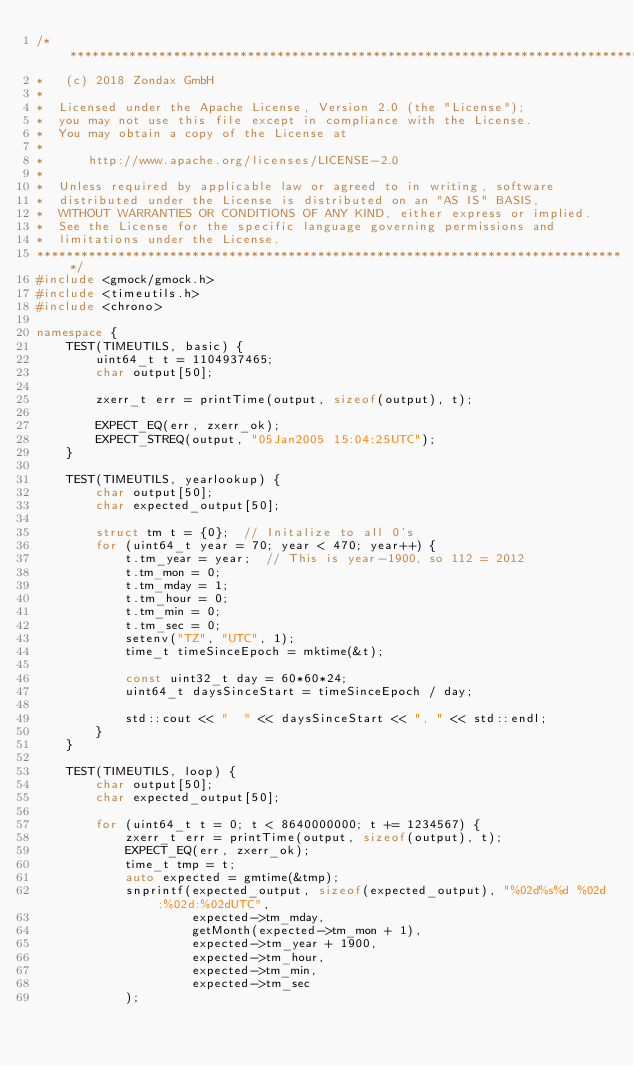<code> <loc_0><loc_0><loc_500><loc_500><_C++_>/*******************************************************************************
*   (c) 2018 Zondax GmbH
*
*  Licensed under the Apache License, Version 2.0 (the "License");
*  you may not use this file except in compliance with the License.
*  You may obtain a copy of the License at
*
*      http://www.apache.org/licenses/LICENSE-2.0
*
*  Unless required by applicable law or agreed to in writing, software
*  distributed under the License is distributed on an "AS IS" BASIS,
*  WITHOUT WARRANTIES OR CONDITIONS OF ANY KIND, either express or implied.
*  See the License for the specific language governing permissions and
*  limitations under the License.
********************************************************************************/
#include <gmock/gmock.h>
#include <timeutils.h>
#include <chrono>

namespace {
    TEST(TIMEUTILS, basic) {
        uint64_t t = 1104937465;
        char output[50];

        zxerr_t err = printTime(output, sizeof(output), t);

        EXPECT_EQ(err, zxerr_ok);
        EXPECT_STREQ(output, "05Jan2005 15:04:25UTC");
    }

    TEST(TIMEUTILS, yearlookup) {
        char output[50];
        char expected_output[50];

        struct tm t = {0};  // Initalize to all 0's
        for (uint64_t year = 70; year < 470; year++) {
            t.tm_year = year;  // This is year-1900, so 112 = 2012
            t.tm_mon = 0;
            t.tm_mday = 1;
            t.tm_hour = 0;
            t.tm_min = 0;
            t.tm_sec = 0;
            setenv("TZ", "UTC", 1);
            time_t timeSinceEpoch = mktime(&t);

            const uint32_t day = 60*60*24;
            uint64_t daysSinceStart = timeSinceEpoch / day;

            std::cout << "  " << daysSinceStart << ", " << std::endl;
        }
    }

    TEST(TIMEUTILS, loop) {
        char output[50];
        char expected_output[50];

        for (uint64_t t = 0; t < 8640000000; t += 1234567) {
            zxerr_t err = printTime(output, sizeof(output), t);
            EXPECT_EQ(err, zxerr_ok);
            time_t tmp = t;
            auto expected = gmtime(&tmp);
            snprintf(expected_output, sizeof(expected_output), "%02d%s%d %02d:%02d:%02dUTC",
                     expected->tm_mday,
                     getMonth(expected->tm_mon + 1),
                     expected->tm_year + 1900,
                     expected->tm_hour,
                     expected->tm_min,
                     expected->tm_sec
            );
</code> 